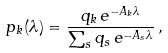<formula> <loc_0><loc_0><loc_500><loc_500>p _ { k } ( \lambda ) = \frac { q _ { k } \, e ^ { - A _ { k } \lambda } } { \sum _ { s } q _ { s } \, e ^ { - A _ { s } \lambda } } \, ,</formula> 